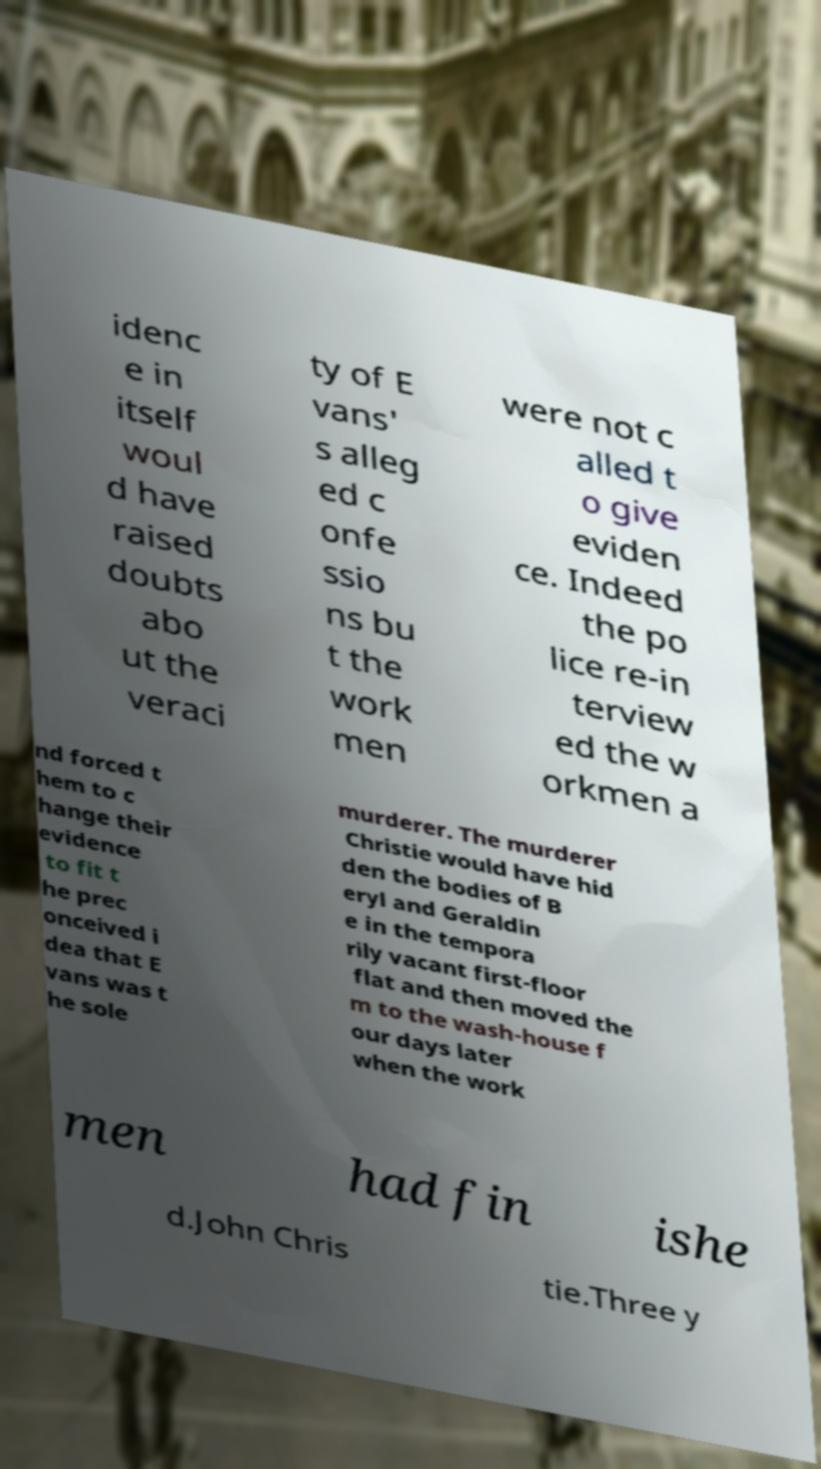Please identify and transcribe the text found in this image. idenc e in itself woul d have raised doubts abo ut the veraci ty of E vans' s alleg ed c onfe ssio ns bu t the work men were not c alled t o give eviden ce. Indeed the po lice re-in terview ed the w orkmen a nd forced t hem to c hange their evidence to fit t he prec onceived i dea that E vans was t he sole murderer. The murderer Christie would have hid den the bodies of B eryl and Geraldin e in the tempora rily vacant first-floor flat and then moved the m to the wash-house f our days later when the work men had fin ishe d.John Chris tie.Three y 